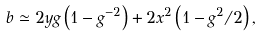<formula> <loc_0><loc_0><loc_500><loc_500>b \simeq 2 y g \left ( 1 - g ^ { - 2 } \right ) + 2 x ^ { 2 } \left ( 1 - g ^ { 2 } / 2 \right ) ,</formula> 